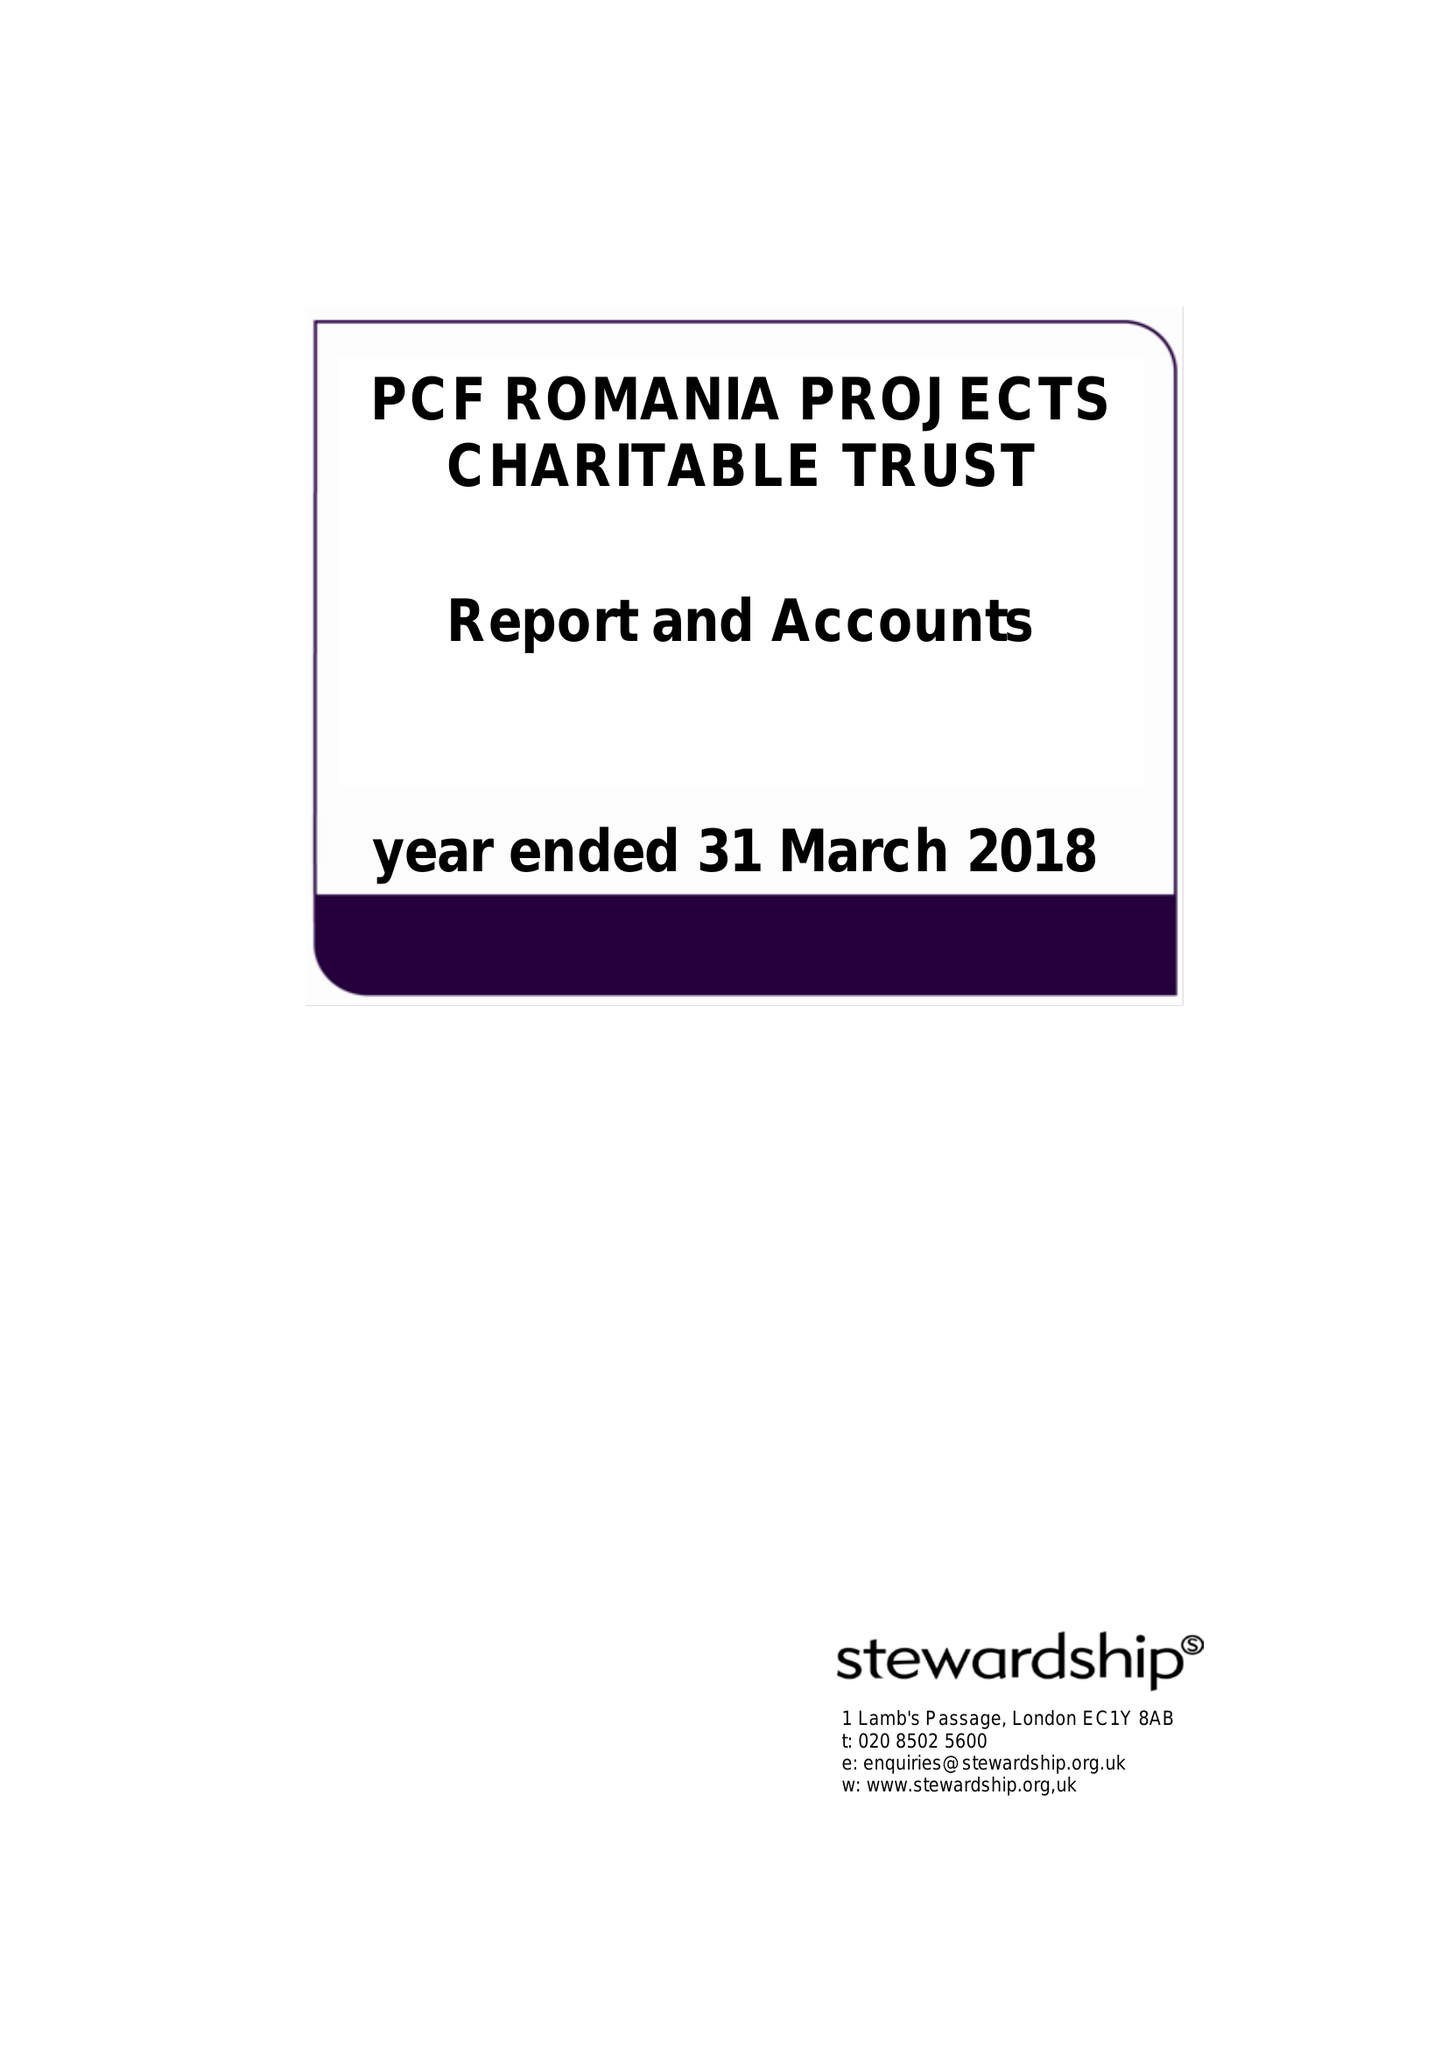What is the value for the spending_annually_in_british_pounds?
Answer the question using a single word or phrase. 81271.00 